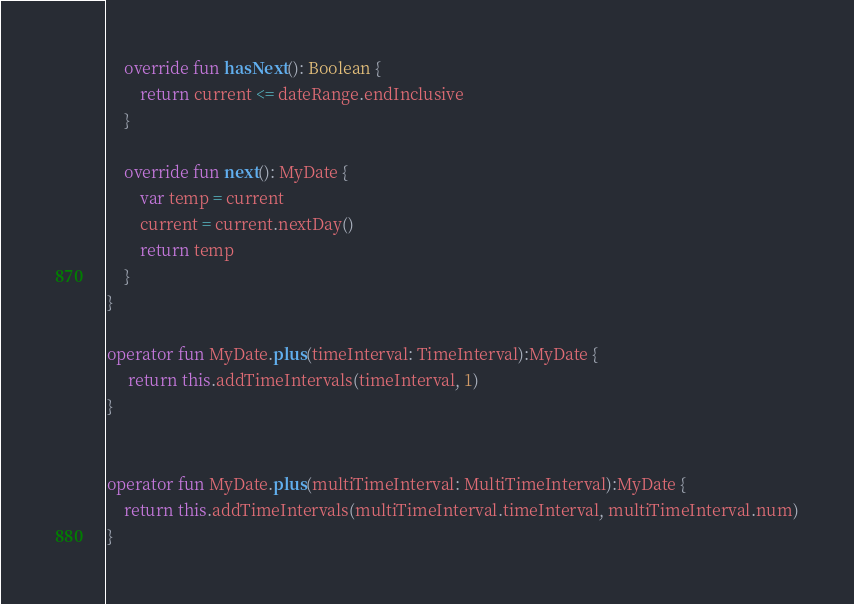<code> <loc_0><loc_0><loc_500><loc_500><_Kotlin_>
    override fun hasNext(): Boolean {
        return current <= dateRange.endInclusive
    }

    override fun next(): MyDate {
        var temp = current
        current = current.nextDay()
        return temp
    }
}

operator fun MyDate.plus(timeInterval: TimeInterval):MyDate {
     return this.addTimeIntervals(timeInterval, 1)
}


operator fun MyDate.plus(multiTimeInterval: MultiTimeInterval):MyDate {
    return this.addTimeIntervals(multiTimeInterval.timeInterval, multiTimeInterval.num)
}

</code> 